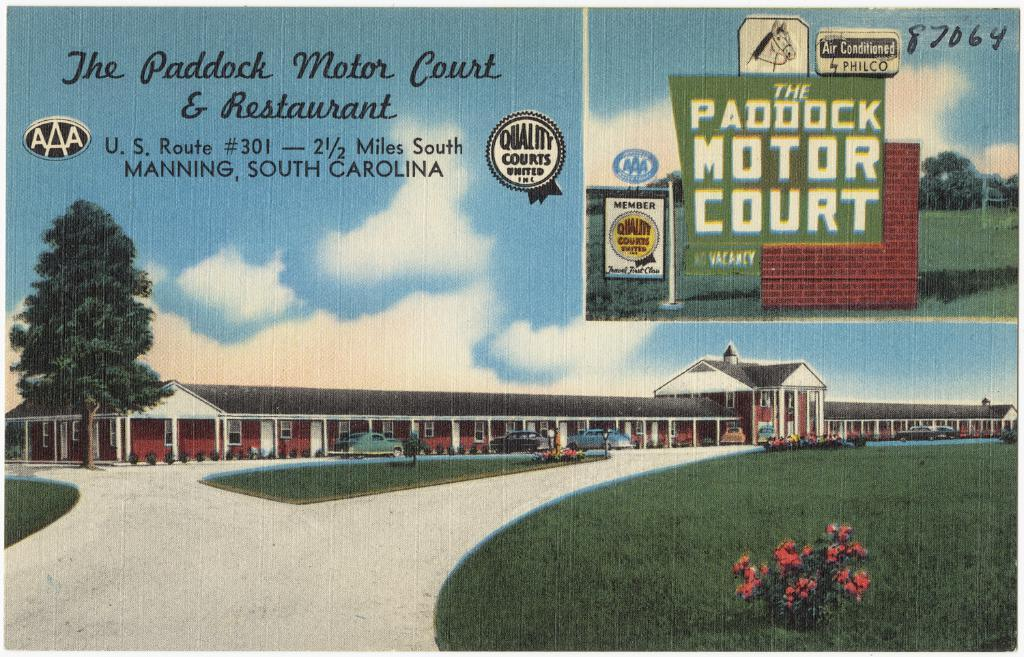<image>
Relay a brief, clear account of the picture shown. a post card for The Paddock Motor Court and Restaurant 